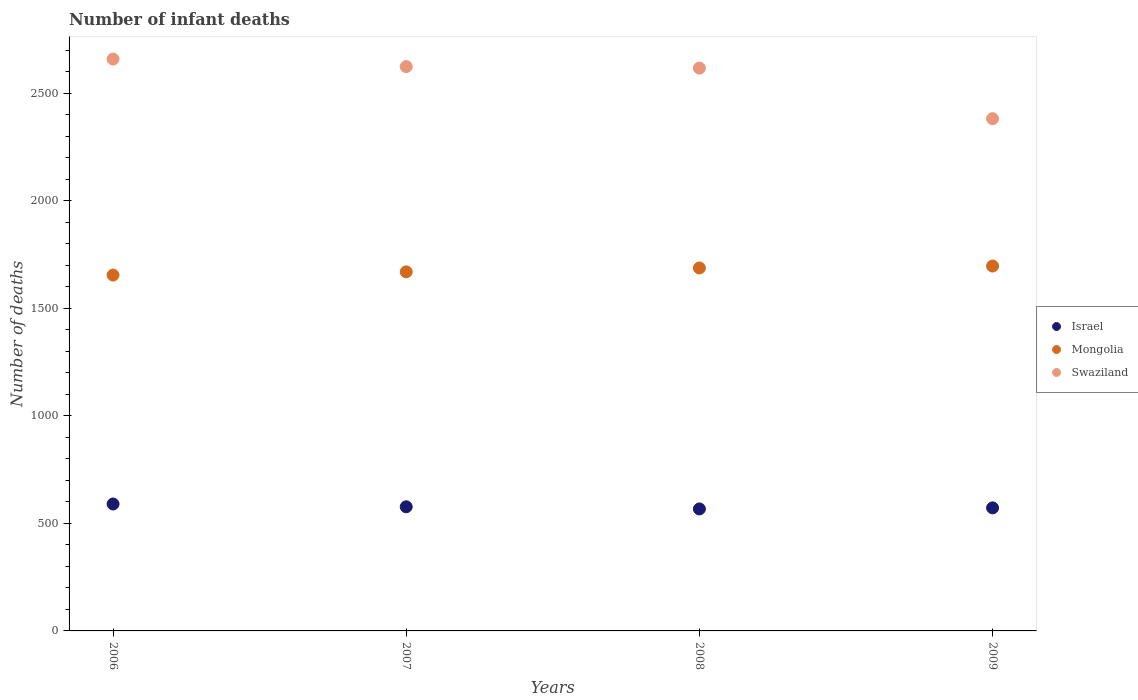How many different coloured dotlines are there?
Provide a succinct answer. 3. Is the number of dotlines equal to the number of legend labels?
Ensure brevity in your answer.  Yes. What is the number of infant deaths in Israel in 2008?
Keep it short and to the point. 567. Across all years, what is the maximum number of infant deaths in Israel?
Offer a terse response. 590. Across all years, what is the minimum number of infant deaths in Swaziland?
Give a very brief answer. 2381. In which year was the number of infant deaths in Mongolia minimum?
Give a very brief answer. 2006. What is the total number of infant deaths in Swaziland in the graph?
Provide a short and direct response. 1.03e+04. What is the difference between the number of infant deaths in Mongolia in 2006 and that in 2007?
Ensure brevity in your answer.  -15. What is the difference between the number of infant deaths in Israel in 2007 and the number of infant deaths in Mongolia in 2009?
Offer a terse response. -1119. What is the average number of infant deaths in Israel per year?
Provide a succinct answer. 576.5. In the year 2008, what is the difference between the number of infant deaths in Israel and number of infant deaths in Mongolia?
Ensure brevity in your answer.  -1120. What is the ratio of the number of infant deaths in Swaziland in 2006 to that in 2007?
Provide a short and direct response. 1.01. Is the number of infant deaths in Israel in 2007 less than that in 2009?
Make the answer very short. No. Is the difference between the number of infant deaths in Israel in 2007 and 2009 greater than the difference between the number of infant deaths in Mongolia in 2007 and 2009?
Offer a very short reply. Yes. What is the difference between the highest and the lowest number of infant deaths in Swaziland?
Keep it short and to the point. 277. Is it the case that in every year, the sum of the number of infant deaths in Israel and number of infant deaths in Mongolia  is greater than the number of infant deaths in Swaziland?
Offer a very short reply. No. Is the number of infant deaths in Israel strictly less than the number of infant deaths in Mongolia over the years?
Your answer should be compact. Yes. What is the difference between two consecutive major ticks on the Y-axis?
Ensure brevity in your answer.  500. Does the graph contain any zero values?
Provide a succinct answer. No. What is the title of the graph?
Offer a terse response. Number of infant deaths. What is the label or title of the X-axis?
Your answer should be compact. Years. What is the label or title of the Y-axis?
Your answer should be very brief. Number of deaths. What is the Number of deaths in Israel in 2006?
Offer a very short reply. 590. What is the Number of deaths of Mongolia in 2006?
Provide a succinct answer. 1654. What is the Number of deaths of Swaziland in 2006?
Make the answer very short. 2658. What is the Number of deaths in Israel in 2007?
Provide a short and direct response. 577. What is the Number of deaths in Mongolia in 2007?
Give a very brief answer. 1669. What is the Number of deaths of Swaziland in 2007?
Your answer should be very brief. 2623. What is the Number of deaths of Israel in 2008?
Your answer should be compact. 567. What is the Number of deaths of Mongolia in 2008?
Provide a succinct answer. 1687. What is the Number of deaths of Swaziland in 2008?
Your answer should be very brief. 2616. What is the Number of deaths in Israel in 2009?
Offer a terse response. 572. What is the Number of deaths in Mongolia in 2009?
Your response must be concise. 1696. What is the Number of deaths in Swaziland in 2009?
Your answer should be compact. 2381. Across all years, what is the maximum Number of deaths in Israel?
Your response must be concise. 590. Across all years, what is the maximum Number of deaths of Mongolia?
Your answer should be very brief. 1696. Across all years, what is the maximum Number of deaths of Swaziland?
Offer a terse response. 2658. Across all years, what is the minimum Number of deaths in Israel?
Your answer should be compact. 567. Across all years, what is the minimum Number of deaths of Mongolia?
Make the answer very short. 1654. Across all years, what is the minimum Number of deaths in Swaziland?
Keep it short and to the point. 2381. What is the total Number of deaths of Israel in the graph?
Keep it short and to the point. 2306. What is the total Number of deaths of Mongolia in the graph?
Keep it short and to the point. 6706. What is the total Number of deaths of Swaziland in the graph?
Your answer should be compact. 1.03e+04. What is the difference between the Number of deaths of Israel in 2006 and that in 2007?
Provide a succinct answer. 13. What is the difference between the Number of deaths in Mongolia in 2006 and that in 2007?
Ensure brevity in your answer.  -15. What is the difference between the Number of deaths in Mongolia in 2006 and that in 2008?
Offer a very short reply. -33. What is the difference between the Number of deaths in Swaziland in 2006 and that in 2008?
Your response must be concise. 42. What is the difference between the Number of deaths of Mongolia in 2006 and that in 2009?
Keep it short and to the point. -42. What is the difference between the Number of deaths in Swaziland in 2006 and that in 2009?
Ensure brevity in your answer.  277. What is the difference between the Number of deaths of Mongolia in 2007 and that in 2008?
Keep it short and to the point. -18. What is the difference between the Number of deaths in Israel in 2007 and that in 2009?
Your answer should be very brief. 5. What is the difference between the Number of deaths in Mongolia in 2007 and that in 2009?
Offer a very short reply. -27. What is the difference between the Number of deaths in Swaziland in 2007 and that in 2009?
Provide a short and direct response. 242. What is the difference between the Number of deaths of Israel in 2008 and that in 2009?
Keep it short and to the point. -5. What is the difference between the Number of deaths in Swaziland in 2008 and that in 2009?
Offer a terse response. 235. What is the difference between the Number of deaths of Israel in 2006 and the Number of deaths of Mongolia in 2007?
Give a very brief answer. -1079. What is the difference between the Number of deaths of Israel in 2006 and the Number of deaths of Swaziland in 2007?
Keep it short and to the point. -2033. What is the difference between the Number of deaths in Mongolia in 2006 and the Number of deaths in Swaziland in 2007?
Provide a succinct answer. -969. What is the difference between the Number of deaths in Israel in 2006 and the Number of deaths in Mongolia in 2008?
Ensure brevity in your answer.  -1097. What is the difference between the Number of deaths in Israel in 2006 and the Number of deaths in Swaziland in 2008?
Make the answer very short. -2026. What is the difference between the Number of deaths in Mongolia in 2006 and the Number of deaths in Swaziland in 2008?
Provide a short and direct response. -962. What is the difference between the Number of deaths of Israel in 2006 and the Number of deaths of Mongolia in 2009?
Your response must be concise. -1106. What is the difference between the Number of deaths in Israel in 2006 and the Number of deaths in Swaziland in 2009?
Your response must be concise. -1791. What is the difference between the Number of deaths of Mongolia in 2006 and the Number of deaths of Swaziland in 2009?
Your answer should be compact. -727. What is the difference between the Number of deaths of Israel in 2007 and the Number of deaths of Mongolia in 2008?
Keep it short and to the point. -1110. What is the difference between the Number of deaths of Israel in 2007 and the Number of deaths of Swaziland in 2008?
Give a very brief answer. -2039. What is the difference between the Number of deaths of Mongolia in 2007 and the Number of deaths of Swaziland in 2008?
Provide a short and direct response. -947. What is the difference between the Number of deaths of Israel in 2007 and the Number of deaths of Mongolia in 2009?
Provide a short and direct response. -1119. What is the difference between the Number of deaths of Israel in 2007 and the Number of deaths of Swaziland in 2009?
Keep it short and to the point. -1804. What is the difference between the Number of deaths of Mongolia in 2007 and the Number of deaths of Swaziland in 2009?
Make the answer very short. -712. What is the difference between the Number of deaths in Israel in 2008 and the Number of deaths in Mongolia in 2009?
Ensure brevity in your answer.  -1129. What is the difference between the Number of deaths in Israel in 2008 and the Number of deaths in Swaziland in 2009?
Give a very brief answer. -1814. What is the difference between the Number of deaths in Mongolia in 2008 and the Number of deaths in Swaziland in 2009?
Provide a short and direct response. -694. What is the average Number of deaths in Israel per year?
Make the answer very short. 576.5. What is the average Number of deaths in Mongolia per year?
Give a very brief answer. 1676.5. What is the average Number of deaths of Swaziland per year?
Give a very brief answer. 2569.5. In the year 2006, what is the difference between the Number of deaths of Israel and Number of deaths of Mongolia?
Your answer should be compact. -1064. In the year 2006, what is the difference between the Number of deaths in Israel and Number of deaths in Swaziland?
Your answer should be compact. -2068. In the year 2006, what is the difference between the Number of deaths of Mongolia and Number of deaths of Swaziland?
Provide a short and direct response. -1004. In the year 2007, what is the difference between the Number of deaths of Israel and Number of deaths of Mongolia?
Your response must be concise. -1092. In the year 2007, what is the difference between the Number of deaths of Israel and Number of deaths of Swaziland?
Provide a succinct answer. -2046. In the year 2007, what is the difference between the Number of deaths in Mongolia and Number of deaths in Swaziland?
Keep it short and to the point. -954. In the year 2008, what is the difference between the Number of deaths in Israel and Number of deaths in Mongolia?
Provide a succinct answer. -1120. In the year 2008, what is the difference between the Number of deaths of Israel and Number of deaths of Swaziland?
Provide a short and direct response. -2049. In the year 2008, what is the difference between the Number of deaths in Mongolia and Number of deaths in Swaziland?
Ensure brevity in your answer.  -929. In the year 2009, what is the difference between the Number of deaths in Israel and Number of deaths in Mongolia?
Provide a short and direct response. -1124. In the year 2009, what is the difference between the Number of deaths in Israel and Number of deaths in Swaziland?
Ensure brevity in your answer.  -1809. In the year 2009, what is the difference between the Number of deaths in Mongolia and Number of deaths in Swaziland?
Provide a succinct answer. -685. What is the ratio of the Number of deaths of Israel in 2006 to that in 2007?
Provide a short and direct response. 1.02. What is the ratio of the Number of deaths in Mongolia in 2006 to that in 2007?
Offer a very short reply. 0.99. What is the ratio of the Number of deaths of Swaziland in 2006 to that in 2007?
Ensure brevity in your answer.  1.01. What is the ratio of the Number of deaths of Israel in 2006 to that in 2008?
Keep it short and to the point. 1.04. What is the ratio of the Number of deaths in Mongolia in 2006 to that in 2008?
Make the answer very short. 0.98. What is the ratio of the Number of deaths of Swaziland in 2006 to that in 2008?
Provide a short and direct response. 1.02. What is the ratio of the Number of deaths of Israel in 2006 to that in 2009?
Provide a succinct answer. 1.03. What is the ratio of the Number of deaths of Mongolia in 2006 to that in 2009?
Give a very brief answer. 0.98. What is the ratio of the Number of deaths of Swaziland in 2006 to that in 2009?
Give a very brief answer. 1.12. What is the ratio of the Number of deaths of Israel in 2007 to that in 2008?
Give a very brief answer. 1.02. What is the ratio of the Number of deaths in Mongolia in 2007 to that in 2008?
Offer a terse response. 0.99. What is the ratio of the Number of deaths of Israel in 2007 to that in 2009?
Your response must be concise. 1.01. What is the ratio of the Number of deaths in Mongolia in 2007 to that in 2009?
Give a very brief answer. 0.98. What is the ratio of the Number of deaths of Swaziland in 2007 to that in 2009?
Offer a terse response. 1.1. What is the ratio of the Number of deaths of Mongolia in 2008 to that in 2009?
Provide a succinct answer. 0.99. What is the ratio of the Number of deaths of Swaziland in 2008 to that in 2009?
Your answer should be very brief. 1.1. What is the difference between the highest and the second highest Number of deaths of Israel?
Offer a very short reply. 13. What is the difference between the highest and the lowest Number of deaths of Israel?
Give a very brief answer. 23. What is the difference between the highest and the lowest Number of deaths of Mongolia?
Give a very brief answer. 42. What is the difference between the highest and the lowest Number of deaths of Swaziland?
Provide a succinct answer. 277. 